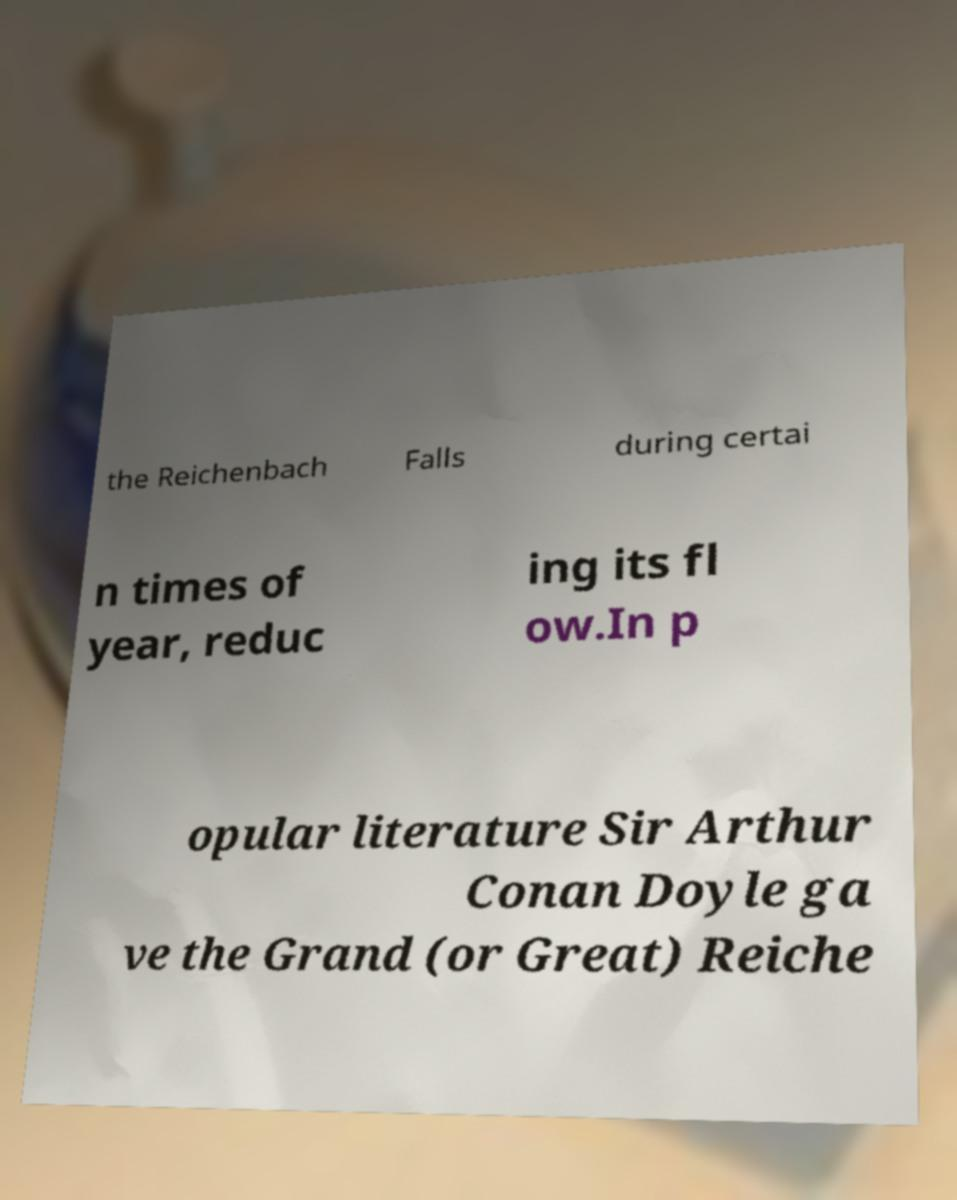Could you assist in decoding the text presented in this image and type it out clearly? the Reichenbach Falls during certai n times of year, reduc ing its fl ow.In p opular literature Sir Arthur Conan Doyle ga ve the Grand (or Great) Reiche 